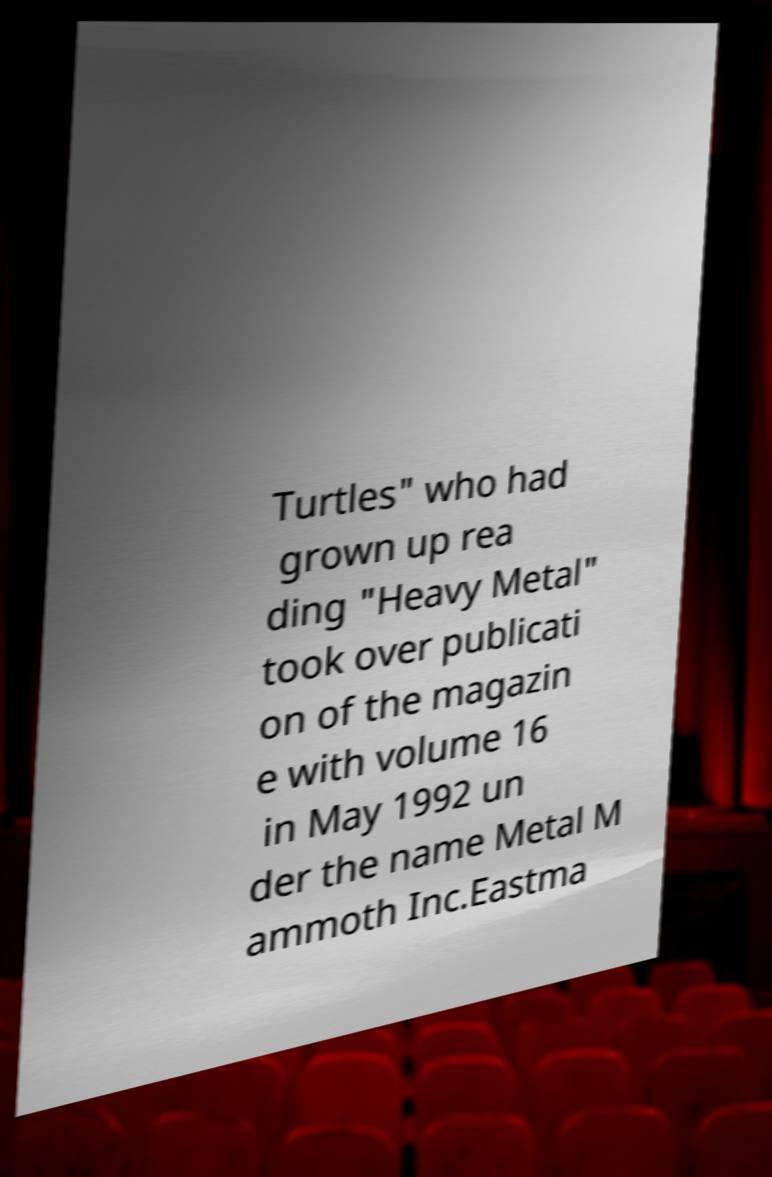Can you read and provide the text displayed in the image?This photo seems to have some interesting text. Can you extract and type it out for me? Turtles" who had grown up rea ding "Heavy Metal" took over publicati on of the magazin e with volume 16 in May 1992 un der the name Metal M ammoth Inc.Eastma 